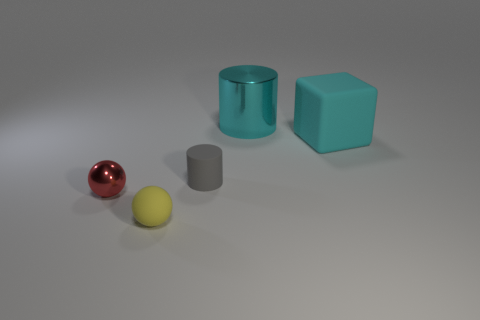Add 3 red metallic balls. How many objects exist? 8 Subtract all spheres. How many objects are left? 3 Subtract all gray objects. Subtract all small rubber balls. How many objects are left? 3 Add 1 big metallic objects. How many big metallic objects are left? 2 Add 2 large gray shiny things. How many large gray shiny things exist? 2 Subtract 0 blue cylinders. How many objects are left? 5 